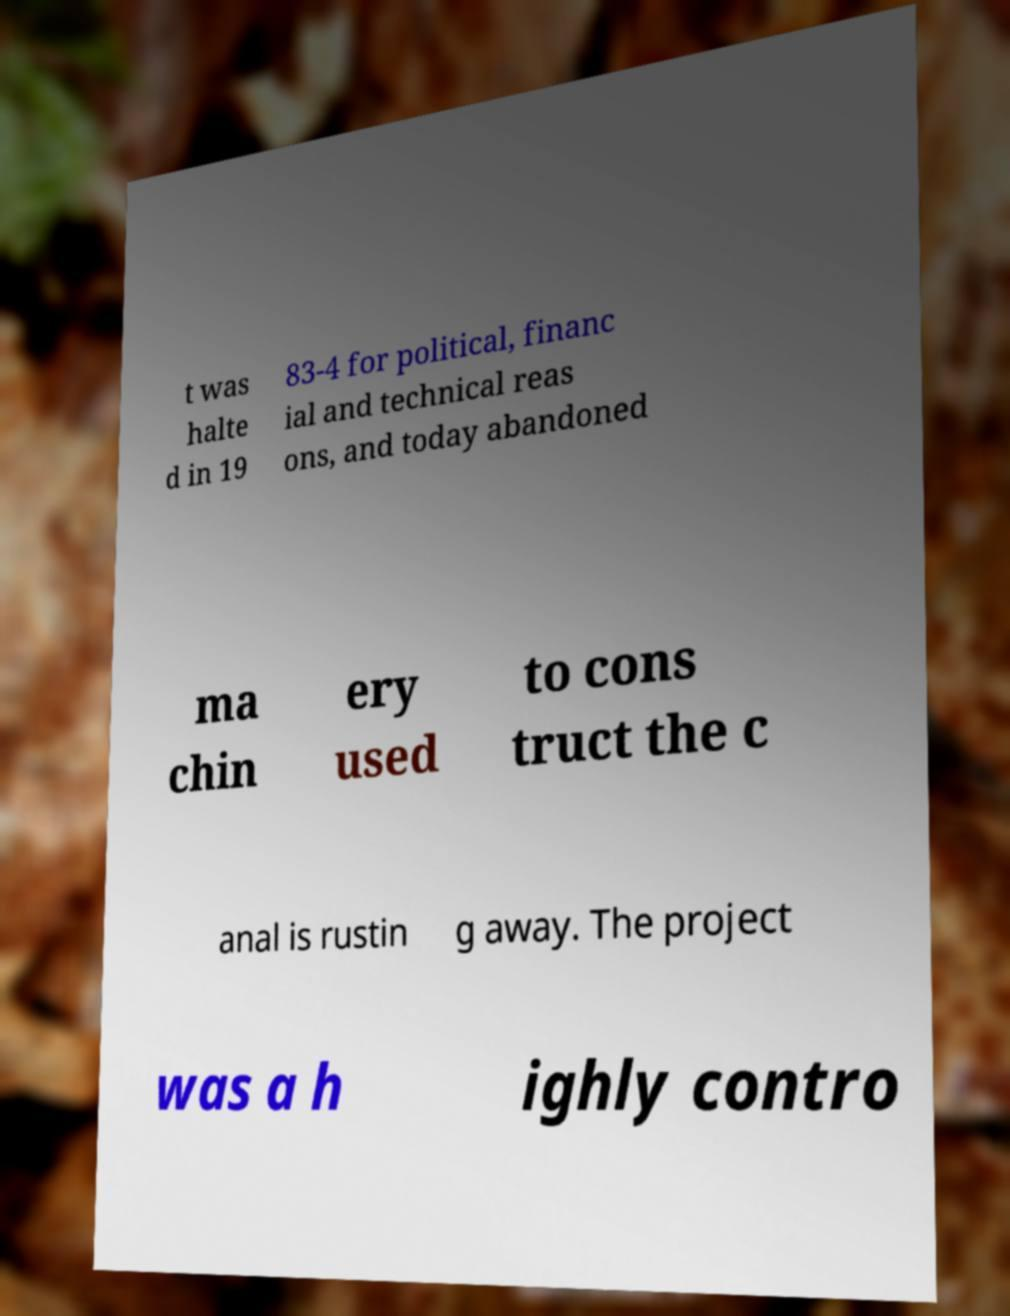Could you assist in decoding the text presented in this image and type it out clearly? t was halte d in 19 83-4 for political, financ ial and technical reas ons, and today abandoned ma chin ery used to cons truct the c anal is rustin g away. The project was a h ighly contro 